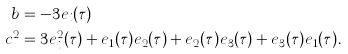Convert formula to latex. <formula><loc_0><loc_0><loc_500><loc_500>b & = - 3 e _ { i } ( \tau ) \\ c ^ { 2 } & = 3 e _ { i } ^ { 2 } ( \tau ) + e _ { 1 } ( \tau ) e _ { 2 } ( \tau ) + e _ { 2 } ( \tau ) e _ { 3 } ( \tau ) + e _ { 3 } ( \tau ) e _ { 1 } ( \tau ) .</formula> 